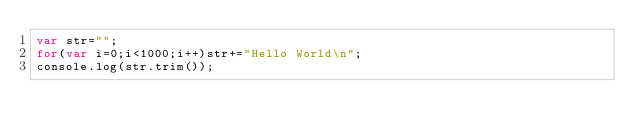Convert code to text. <code><loc_0><loc_0><loc_500><loc_500><_JavaScript_>var str="";
for(var i=0;i<1000;i++)str+="Hello World\n";
console.log(str.trim());</code> 